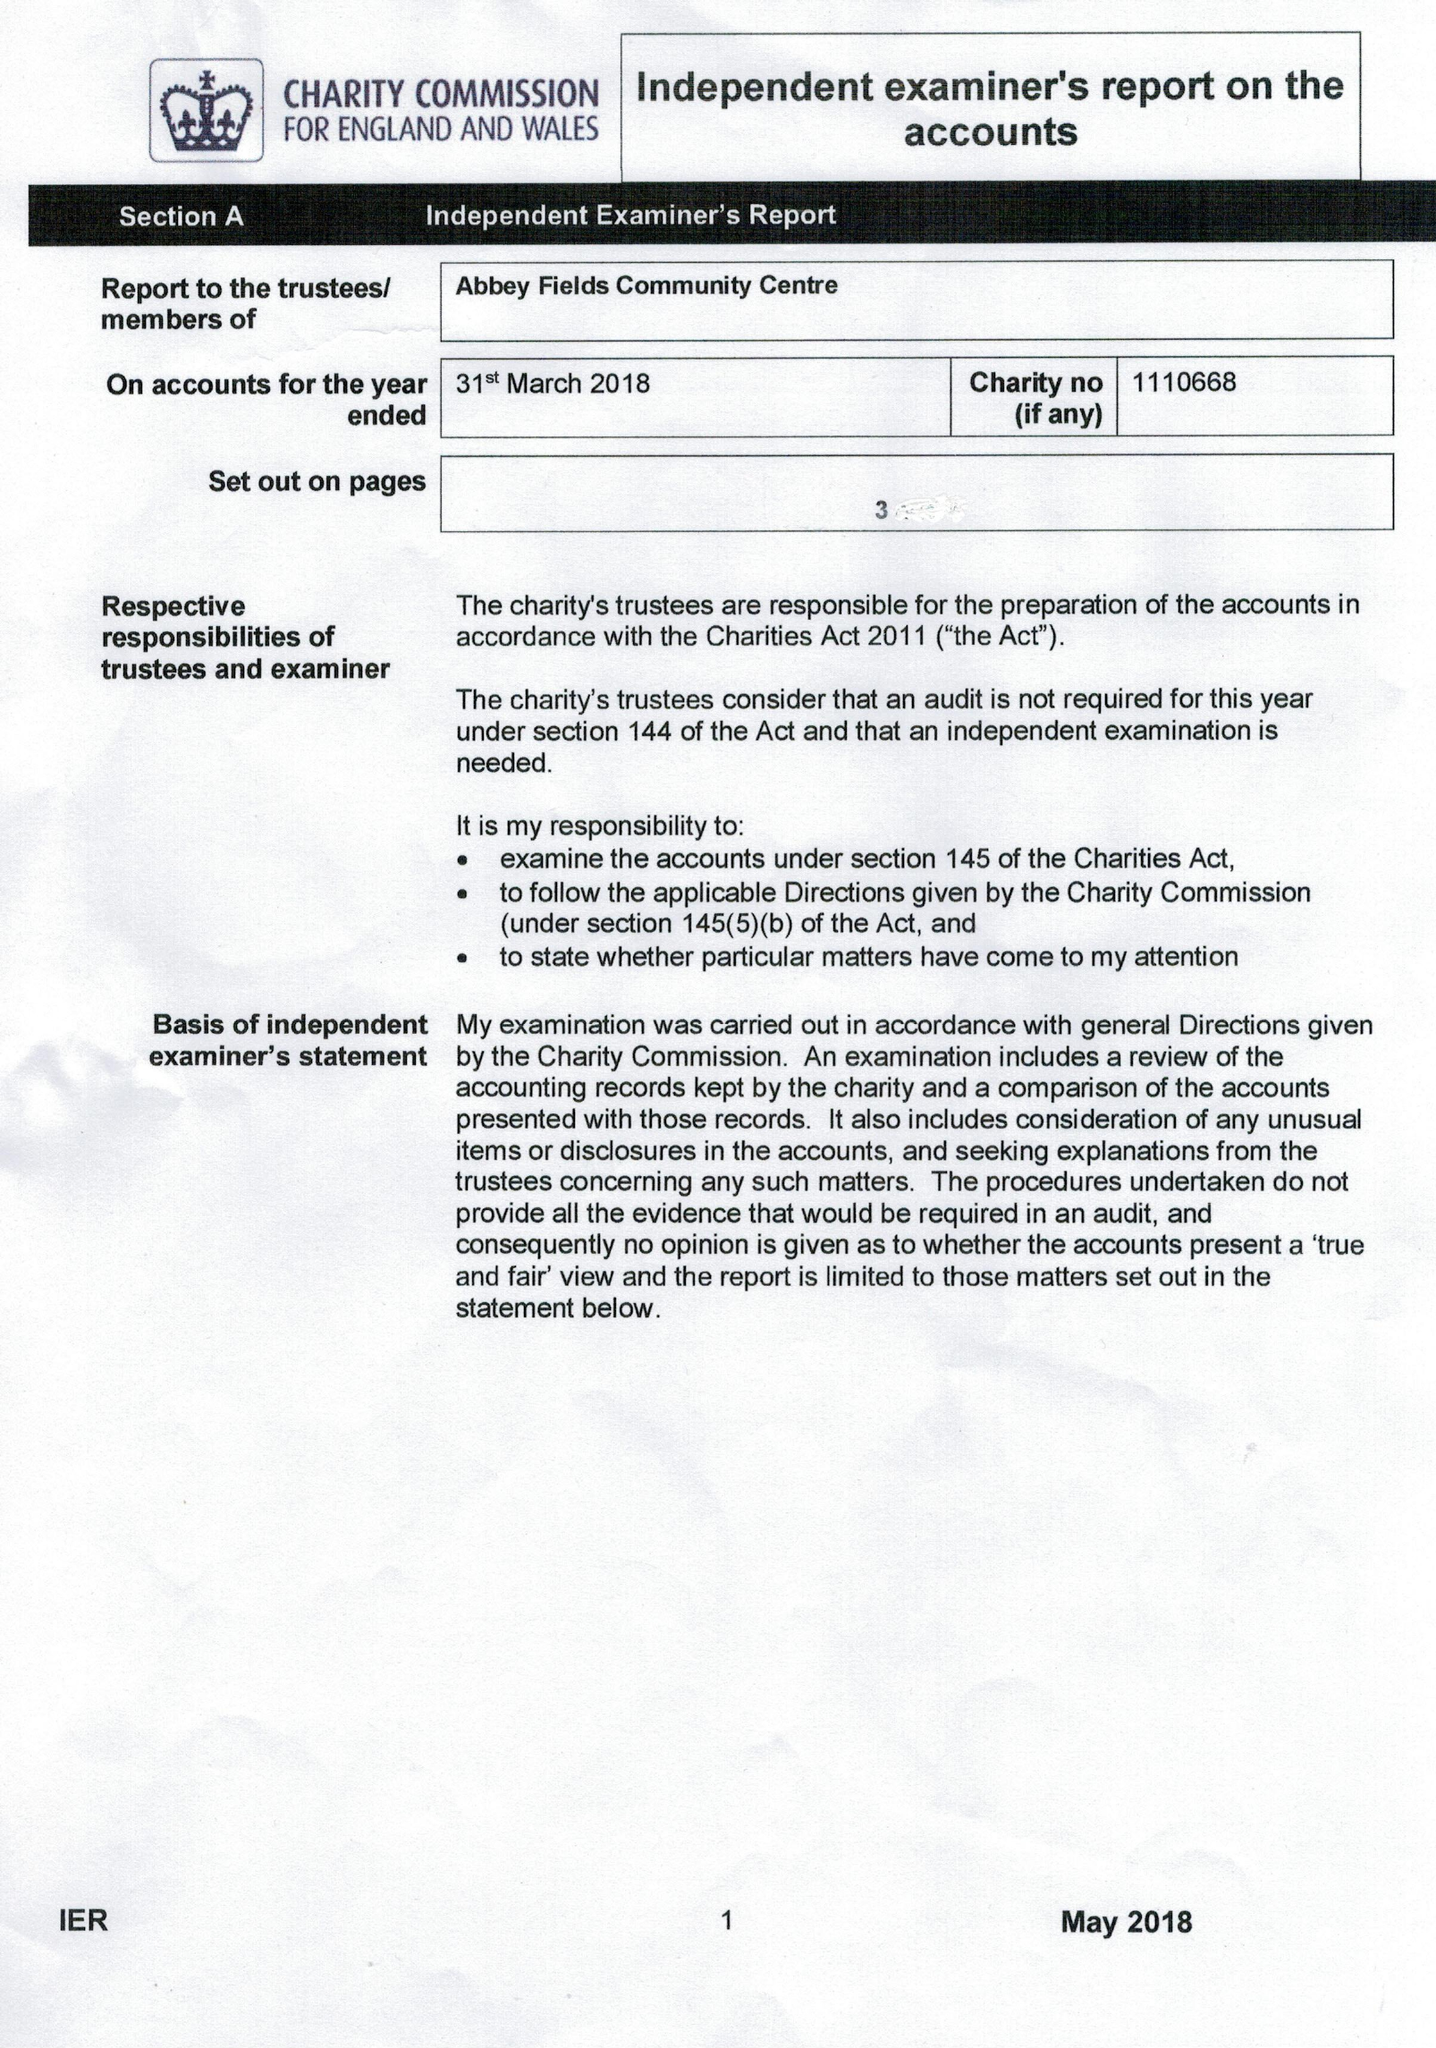What is the value for the address__post_town?
Answer the question using a single word or phrase. CHELTENHAM 